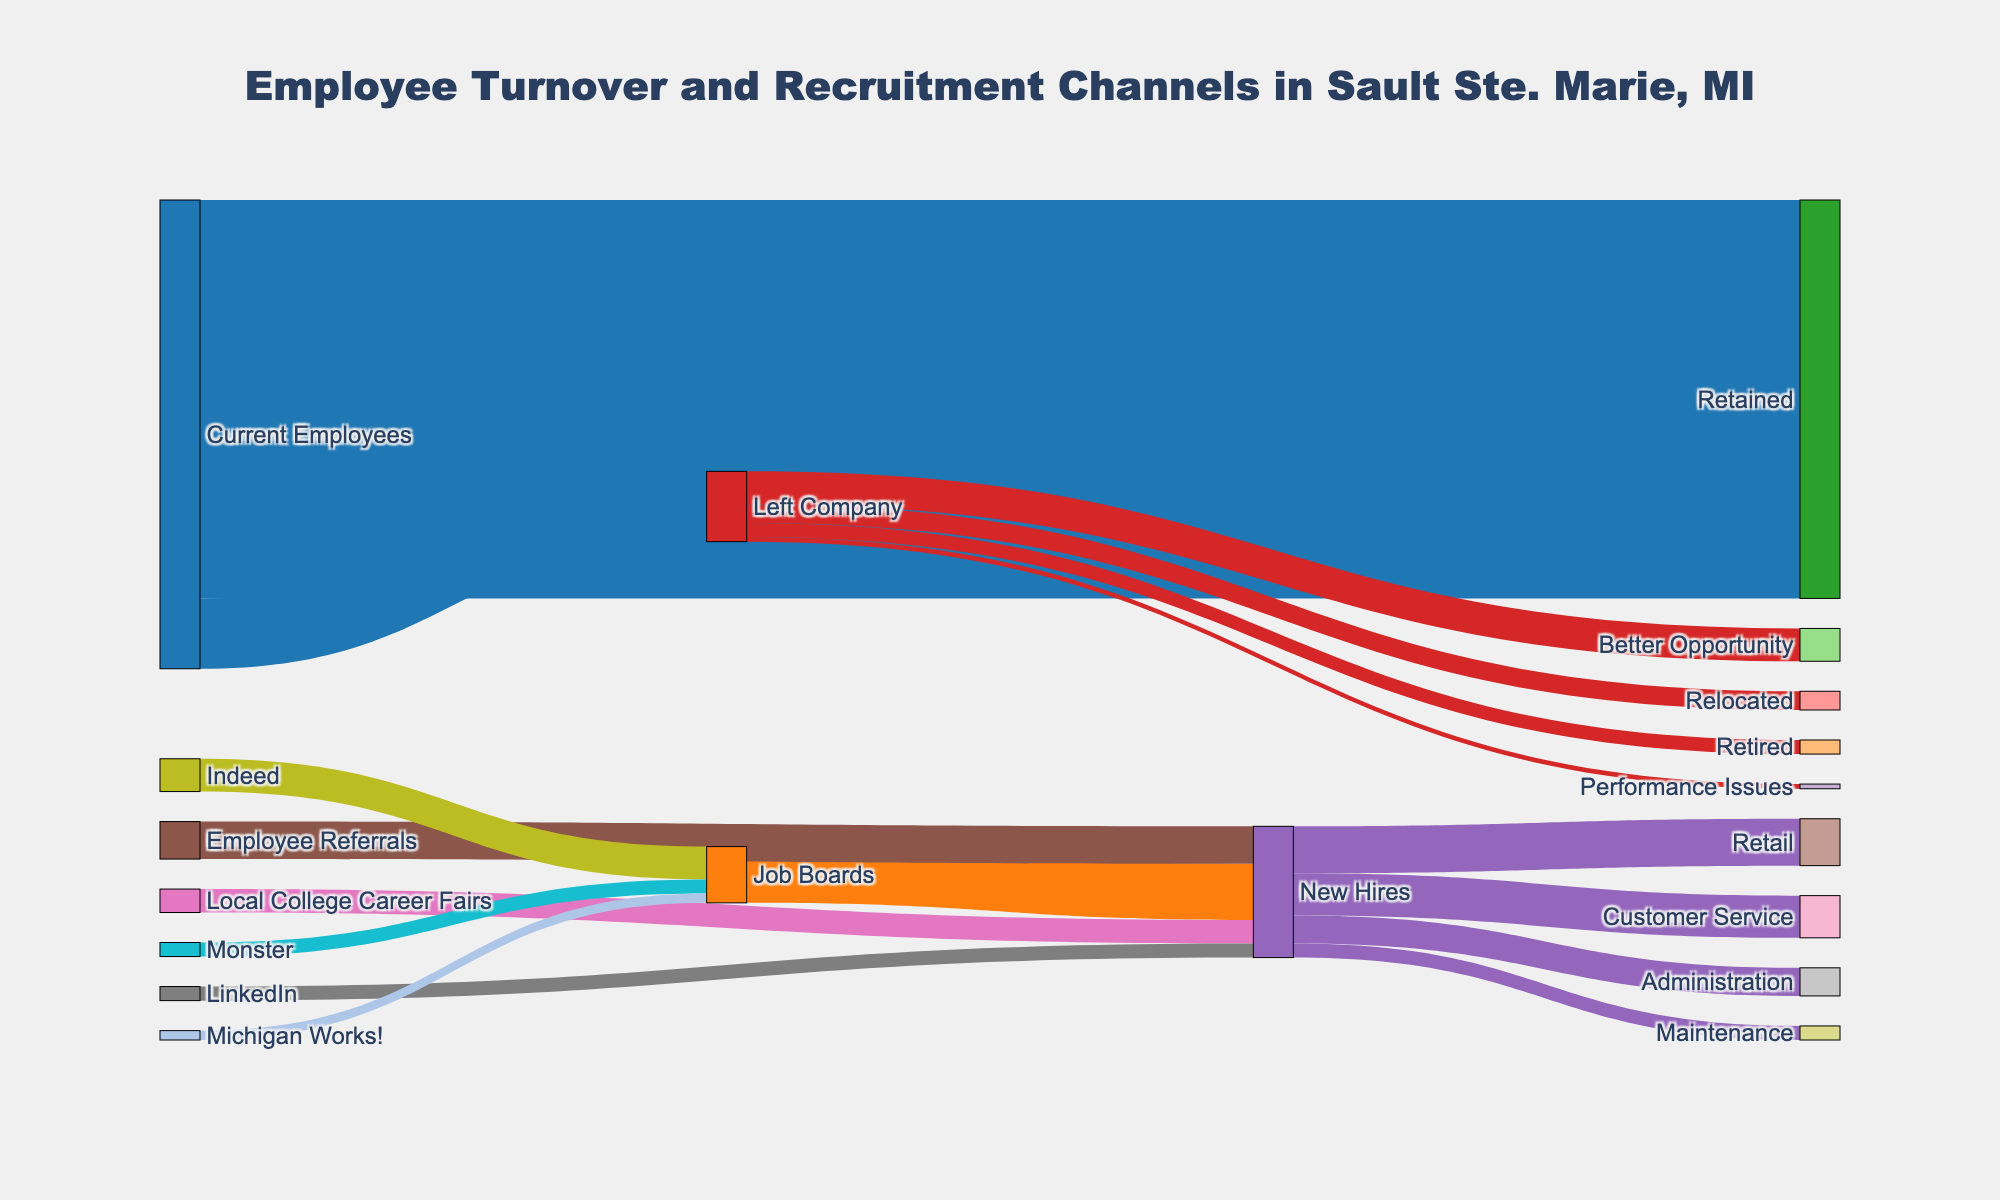What is the title of the figure? The title is displayed at the top of the figure in a larger and bold font. It typically summarizes the content of the chart.
Answer: Employee Turnover and Recruitment Channels in Sault Ste. Marie, MI How many employees were retained? The Sankey diagram shows a flow from "Current Employees" to "Retained," which represents the number of retained employees.
Answer: 85 What is the largest source of new hires? The Sankey diagram shows various sources flowing into "New Hires." The width of the flow from "Job Boards" to "New Hires" is the largest.
Answer: Job Boards Which source contributed the fewest new hires? By observing the flows into "New Hires," "LinkedIn" has the smallest flow.
Answer: LinkedIn How many new hires were recruited through employee referrals and local college career fairs combined? Add the values of new hires from "Employee Referrals" and "Local College Career Fairs" shown in the diagram. 8 (Employee Referrals) + 5 (Local College Career Fairs) = 13
Answer: 13 What category accounts for the majority of employees leaving the company? The Sankey diagram segments employees who left the company into various categories. The flow to "Better Opportunity" is the largest among all categories.
Answer: Better Opportunity Which job board had the highest number of postings? By observing the flows into "Job Boards" from various job posting platforms, "Indeed" has the largest value.
Answer: Indeed Compare the number of employees leaving due to retirement and relocation. Which is greater? Look at the flows from "Left Company” to "Retired" and "Relocated." The value for "Relocated" (4) is greater than for "Retired" (3).
Answer: Relocated Estimate the total number of employees considered in the diagram, including both current and new hires. Current Employees (100) + New Hires (28) = 128 employees considered.
Answer: 128 What sectors do new hires go into, and which one has the most hires? The flows from "New Hires" to various sectors such as Retail, Customer Service, Administration, and Maintenance are shown. "Retail” has the highest number of new hires.
Answer: Retail 